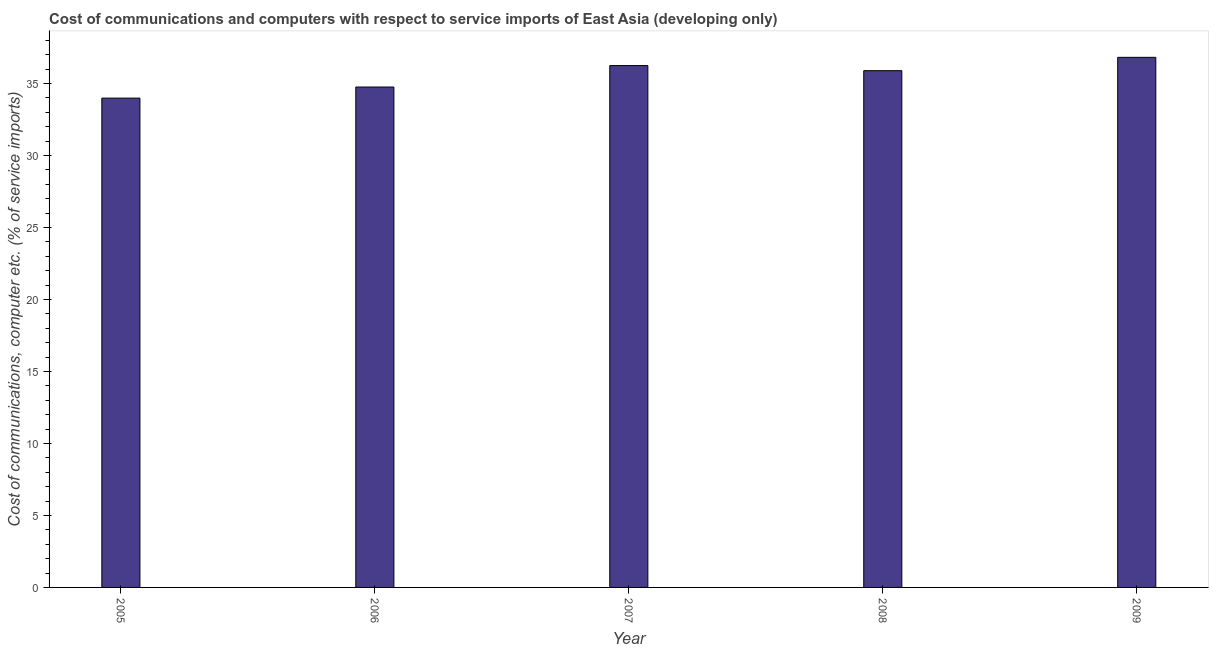Does the graph contain any zero values?
Offer a terse response. No. Does the graph contain grids?
Your answer should be very brief. No. What is the title of the graph?
Give a very brief answer. Cost of communications and computers with respect to service imports of East Asia (developing only). What is the label or title of the Y-axis?
Ensure brevity in your answer.  Cost of communications, computer etc. (% of service imports). What is the cost of communications and computer in 2007?
Offer a very short reply. 36.24. Across all years, what is the maximum cost of communications and computer?
Provide a short and direct response. 36.82. Across all years, what is the minimum cost of communications and computer?
Your response must be concise. 33.98. In which year was the cost of communications and computer maximum?
Keep it short and to the point. 2009. In which year was the cost of communications and computer minimum?
Your response must be concise. 2005. What is the sum of the cost of communications and computer?
Give a very brief answer. 177.69. What is the difference between the cost of communications and computer in 2006 and 2009?
Provide a succinct answer. -2.06. What is the average cost of communications and computer per year?
Provide a short and direct response. 35.54. What is the median cost of communications and computer?
Give a very brief answer. 35.89. Do a majority of the years between 2009 and 2005 (inclusive) have cost of communications and computer greater than 11 %?
Your answer should be very brief. Yes. What is the ratio of the cost of communications and computer in 2005 to that in 2007?
Keep it short and to the point. 0.94. Is the difference between the cost of communications and computer in 2006 and 2009 greater than the difference between any two years?
Offer a very short reply. No. What is the difference between the highest and the second highest cost of communications and computer?
Provide a succinct answer. 0.57. What is the difference between the highest and the lowest cost of communications and computer?
Your response must be concise. 2.83. How many bars are there?
Provide a succinct answer. 5. How many years are there in the graph?
Provide a short and direct response. 5. What is the Cost of communications, computer etc. (% of service imports) in 2005?
Your response must be concise. 33.98. What is the Cost of communications, computer etc. (% of service imports) in 2006?
Make the answer very short. 34.76. What is the Cost of communications, computer etc. (% of service imports) in 2007?
Give a very brief answer. 36.24. What is the Cost of communications, computer etc. (% of service imports) in 2008?
Provide a succinct answer. 35.89. What is the Cost of communications, computer etc. (% of service imports) of 2009?
Provide a succinct answer. 36.82. What is the difference between the Cost of communications, computer etc. (% of service imports) in 2005 and 2006?
Keep it short and to the point. -0.77. What is the difference between the Cost of communications, computer etc. (% of service imports) in 2005 and 2007?
Provide a short and direct response. -2.26. What is the difference between the Cost of communications, computer etc. (% of service imports) in 2005 and 2008?
Your response must be concise. -1.91. What is the difference between the Cost of communications, computer etc. (% of service imports) in 2005 and 2009?
Offer a terse response. -2.83. What is the difference between the Cost of communications, computer etc. (% of service imports) in 2006 and 2007?
Give a very brief answer. -1.49. What is the difference between the Cost of communications, computer etc. (% of service imports) in 2006 and 2008?
Give a very brief answer. -1.14. What is the difference between the Cost of communications, computer etc. (% of service imports) in 2006 and 2009?
Ensure brevity in your answer.  -2.06. What is the difference between the Cost of communications, computer etc. (% of service imports) in 2007 and 2008?
Make the answer very short. 0.35. What is the difference between the Cost of communications, computer etc. (% of service imports) in 2007 and 2009?
Keep it short and to the point. -0.57. What is the difference between the Cost of communications, computer etc. (% of service imports) in 2008 and 2009?
Keep it short and to the point. -0.93. What is the ratio of the Cost of communications, computer etc. (% of service imports) in 2005 to that in 2006?
Your response must be concise. 0.98. What is the ratio of the Cost of communications, computer etc. (% of service imports) in 2005 to that in 2007?
Give a very brief answer. 0.94. What is the ratio of the Cost of communications, computer etc. (% of service imports) in 2005 to that in 2008?
Ensure brevity in your answer.  0.95. What is the ratio of the Cost of communications, computer etc. (% of service imports) in 2005 to that in 2009?
Ensure brevity in your answer.  0.92. What is the ratio of the Cost of communications, computer etc. (% of service imports) in 2006 to that in 2007?
Your answer should be very brief. 0.96. What is the ratio of the Cost of communications, computer etc. (% of service imports) in 2006 to that in 2009?
Provide a succinct answer. 0.94. What is the ratio of the Cost of communications, computer etc. (% of service imports) in 2007 to that in 2008?
Keep it short and to the point. 1.01. What is the ratio of the Cost of communications, computer etc. (% of service imports) in 2007 to that in 2009?
Make the answer very short. 0.98. What is the ratio of the Cost of communications, computer etc. (% of service imports) in 2008 to that in 2009?
Provide a short and direct response. 0.97. 